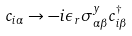<formula> <loc_0><loc_0><loc_500><loc_500>c _ { i \alpha } \rightarrow - i \epsilon _ { r } \sigma ^ { y } _ { \alpha \beta } c ^ { \dagger } _ { i \beta }</formula> 